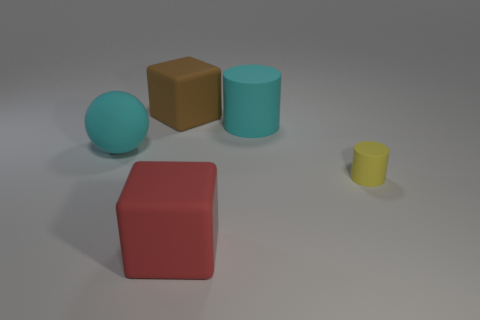Add 3 tiny matte things. How many objects exist? 8 Subtract all blocks. How many objects are left? 3 Add 2 cyan spheres. How many cyan spheres are left? 3 Add 2 big matte things. How many big matte things exist? 6 Subtract 0 red spheres. How many objects are left? 5 Subtract all cyan matte balls. Subtract all large matte spheres. How many objects are left? 3 